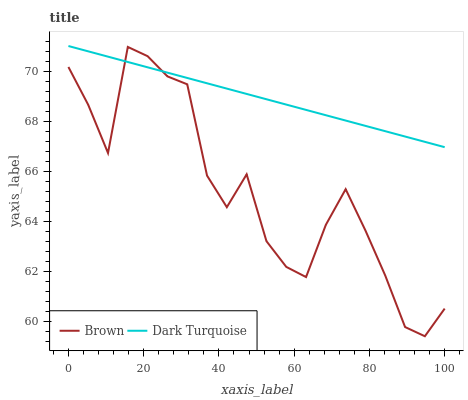Does Dark Turquoise have the minimum area under the curve?
Answer yes or no. No. Is Dark Turquoise the roughest?
Answer yes or no. No. Does Dark Turquoise have the lowest value?
Answer yes or no. No. 